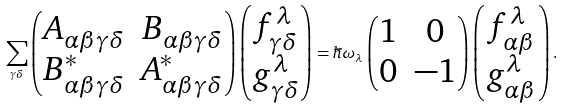Convert formula to latex. <formula><loc_0><loc_0><loc_500><loc_500>\sum _ { \gamma \delta } \begin{pmatrix} A _ { \alpha \beta \gamma \delta } & B _ { \alpha \beta \gamma \delta } \\ B ^ { * } _ { \alpha \beta \gamma \delta } & A ^ { * } _ { \alpha \beta \gamma \delta } \end{pmatrix} \begin{pmatrix} f _ { \gamma \delta } ^ { \lambda } \\ g _ { \gamma \delta } ^ { \lambda } \end{pmatrix} = \hbar { \omega } _ { \lambda } \begin{pmatrix} 1 & 0 \\ 0 & - 1 \end{pmatrix} \begin{pmatrix} f _ { \alpha \beta } ^ { \lambda } \\ g _ { \alpha \beta } ^ { \lambda } \end{pmatrix} .</formula> 